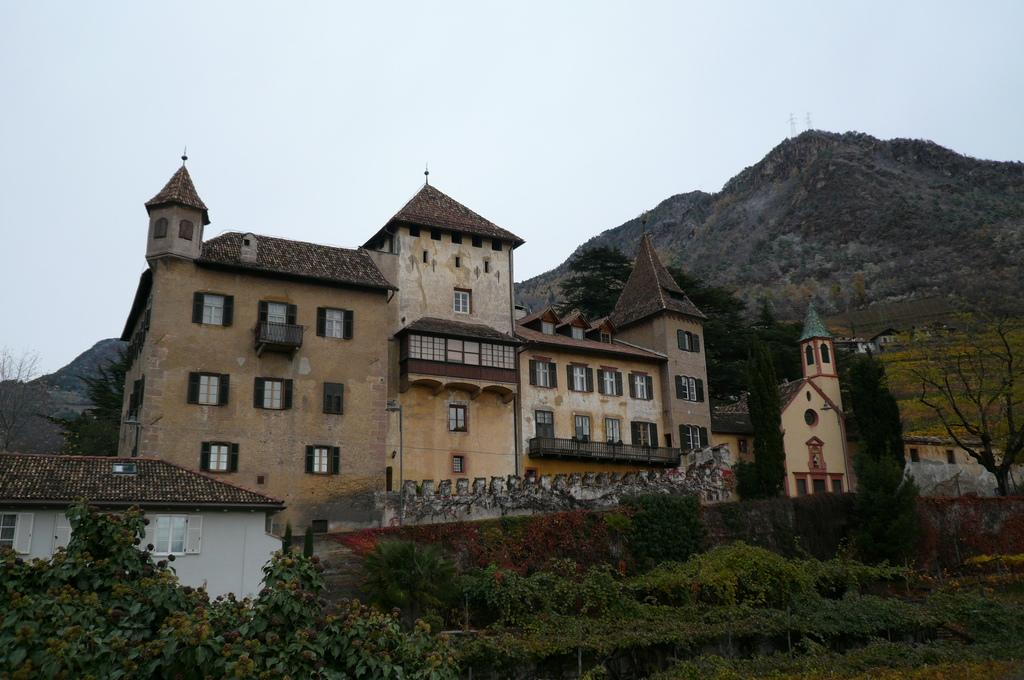What is the main structure in the image? There is a building at the center of the image. What is located in front of the building? There are trees in front of the building. What natural feature can be seen on the right side of the image? There is a mountain on the right side of the image. What is visible in the background of the image? The sky is visible in the background of the image. What type of corn can be seen growing on the building in the image? There is no corn present in the image, and corn does not grow on buildings. 